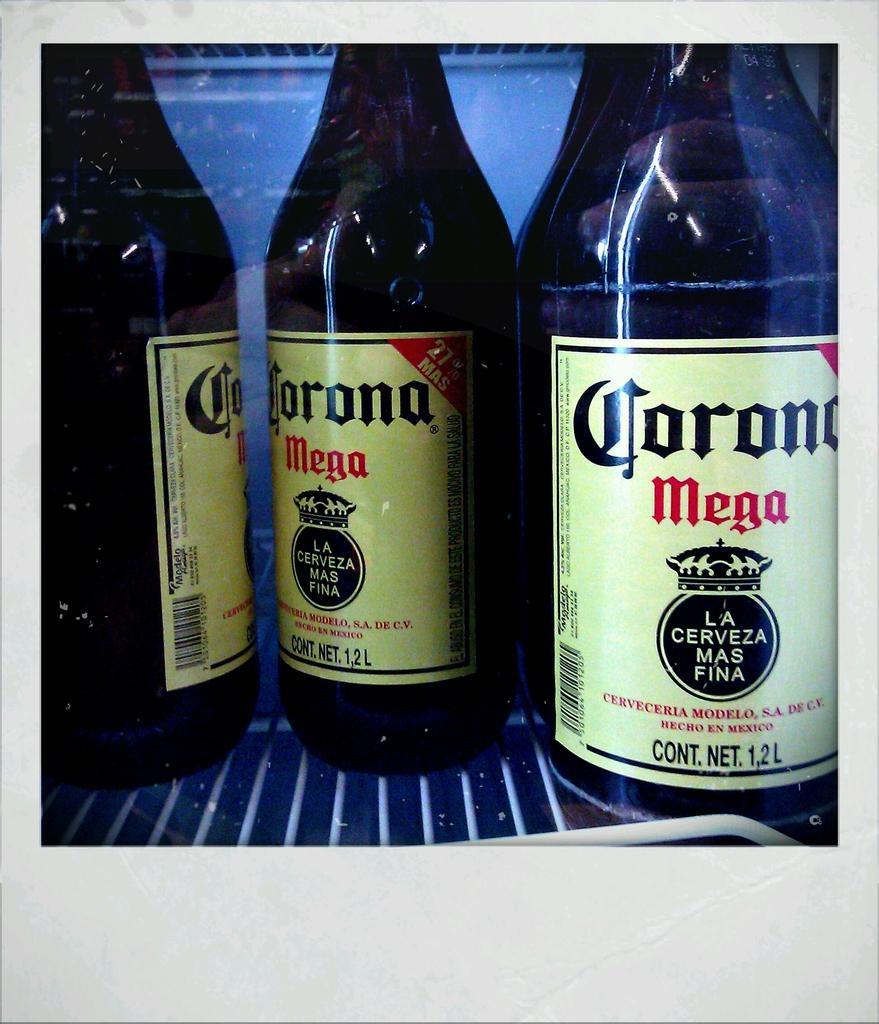Provide a one-sentence caption for the provided image. Several bottles of Corona Mega on a shelf. 